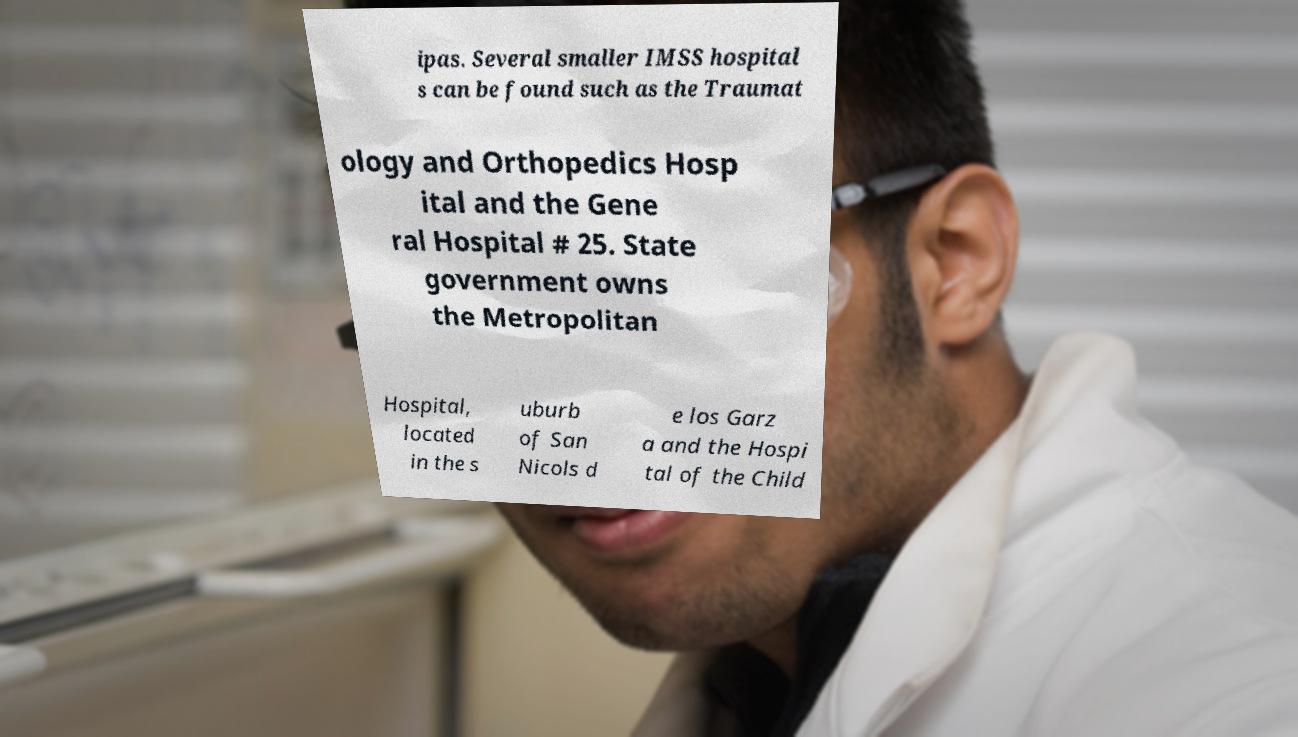Can you accurately transcribe the text from the provided image for me? ipas. Several smaller IMSS hospital s can be found such as the Traumat ology and Orthopedics Hosp ital and the Gene ral Hospital # 25. State government owns the Metropolitan Hospital, located in the s uburb of San Nicols d e los Garz a and the Hospi tal of the Child 